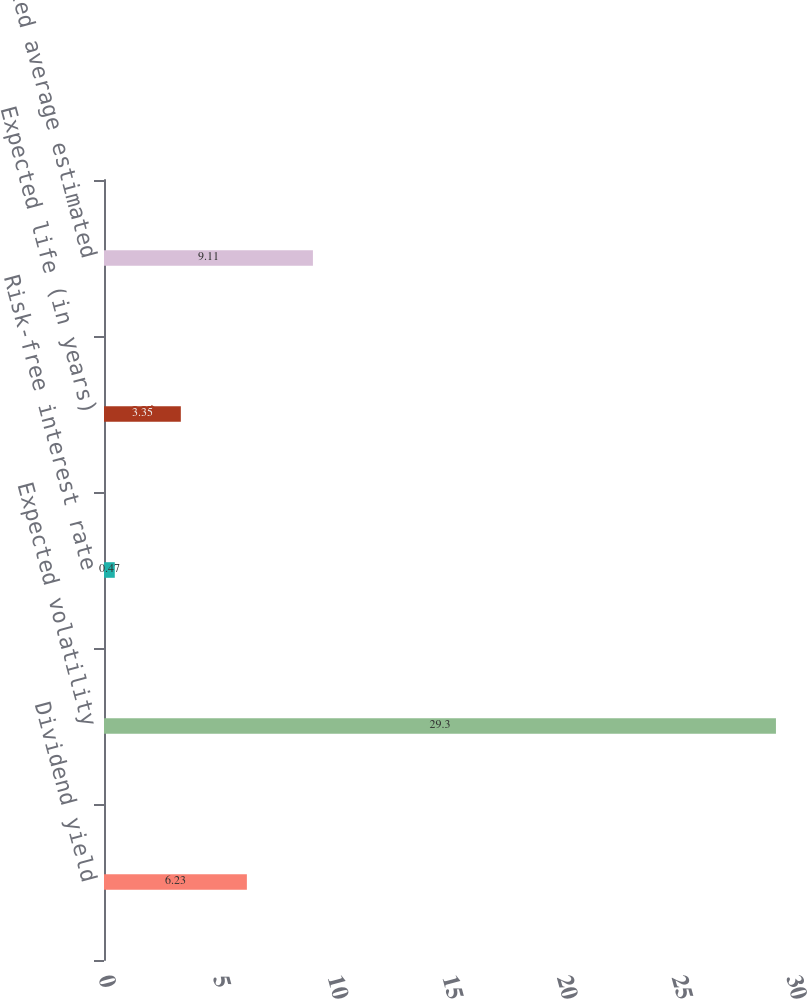Convert chart to OTSL. <chart><loc_0><loc_0><loc_500><loc_500><bar_chart><fcel>Dividend yield<fcel>Expected volatility<fcel>Risk-free interest rate<fcel>Expected life (in years)<fcel>Weighted average estimated<nl><fcel>6.23<fcel>29.3<fcel>0.47<fcel>3.35<fcel>9.11<nl></chart> 